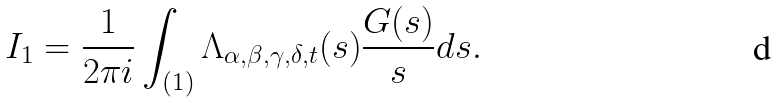Convert formula to latex. <formula><loc_0><loc_0><loc_500><loc_500>I _ { 1 } = \frac { 1 } { 2 \pi i } \int _ { ( 1 ) } \Lambda _ { \alpha , \beta , \gamma , \delta , t } ( s ) \frac { G ( s ) } { s } d s .</formula> 